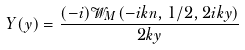<formula> <loc_0><loc_0><loc_500><loc_500>Y ( y ) = \frac { ( - i ) \mathcal { W } _ { M } ( - i k n , 1 / 2 , 2 i k y ) } { 2 k y }</formula> 